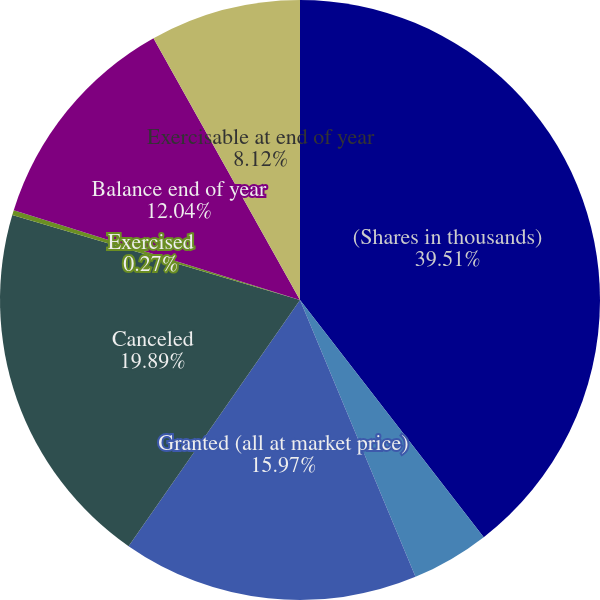<chart> <loc_0><loc_0><loc_500><loc_500><pie_chart><fcel>(Shares in thousands)<fcel>Balance beginning of year<fcel>Granted (all at market price)<fcel>Canceled<fcel>Exercised<fcel>Balance end of year<fcel>Exercisable at end of year<nl><fcel>39.51%<fcel>4.2%<fcel>15.97%<fcel>19.89%<fcel>0.27%<fcel>12.04%<fcel>8.12%<nl></chart> 